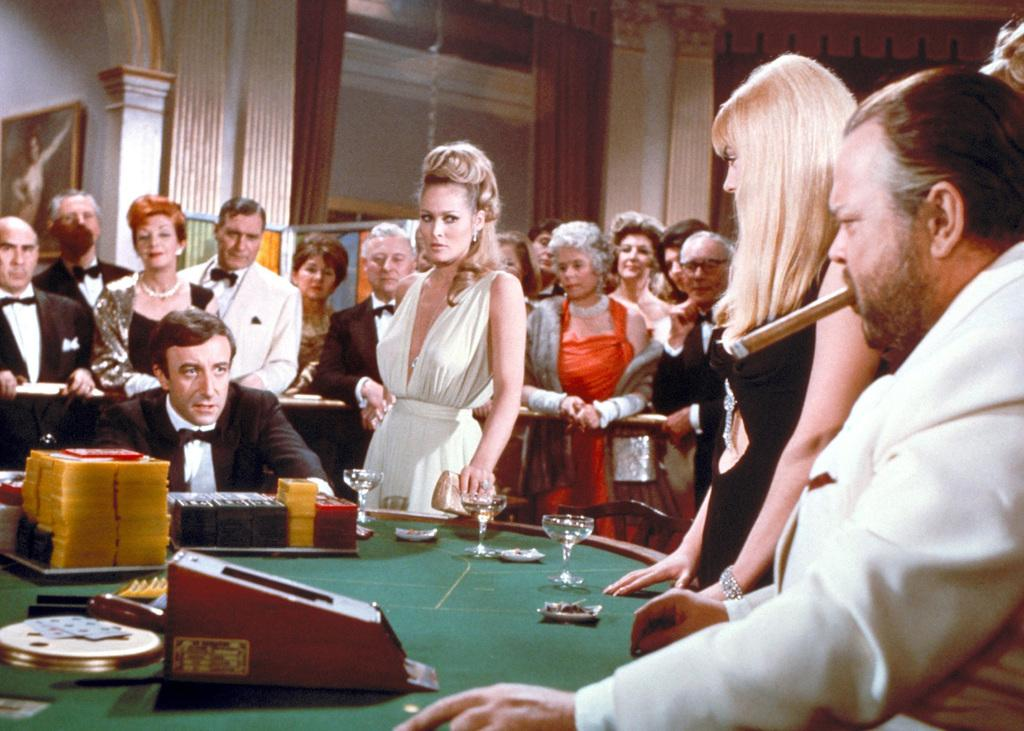What are the people in the image doing? There are people standing and sitting in the image. What can be seen on the table in the image? There are glasses on a table in the image, along with additional items. What is the name of the person's brother who is not present in the image? There is no information about any person's brother in the image, and no names are mentioned. 